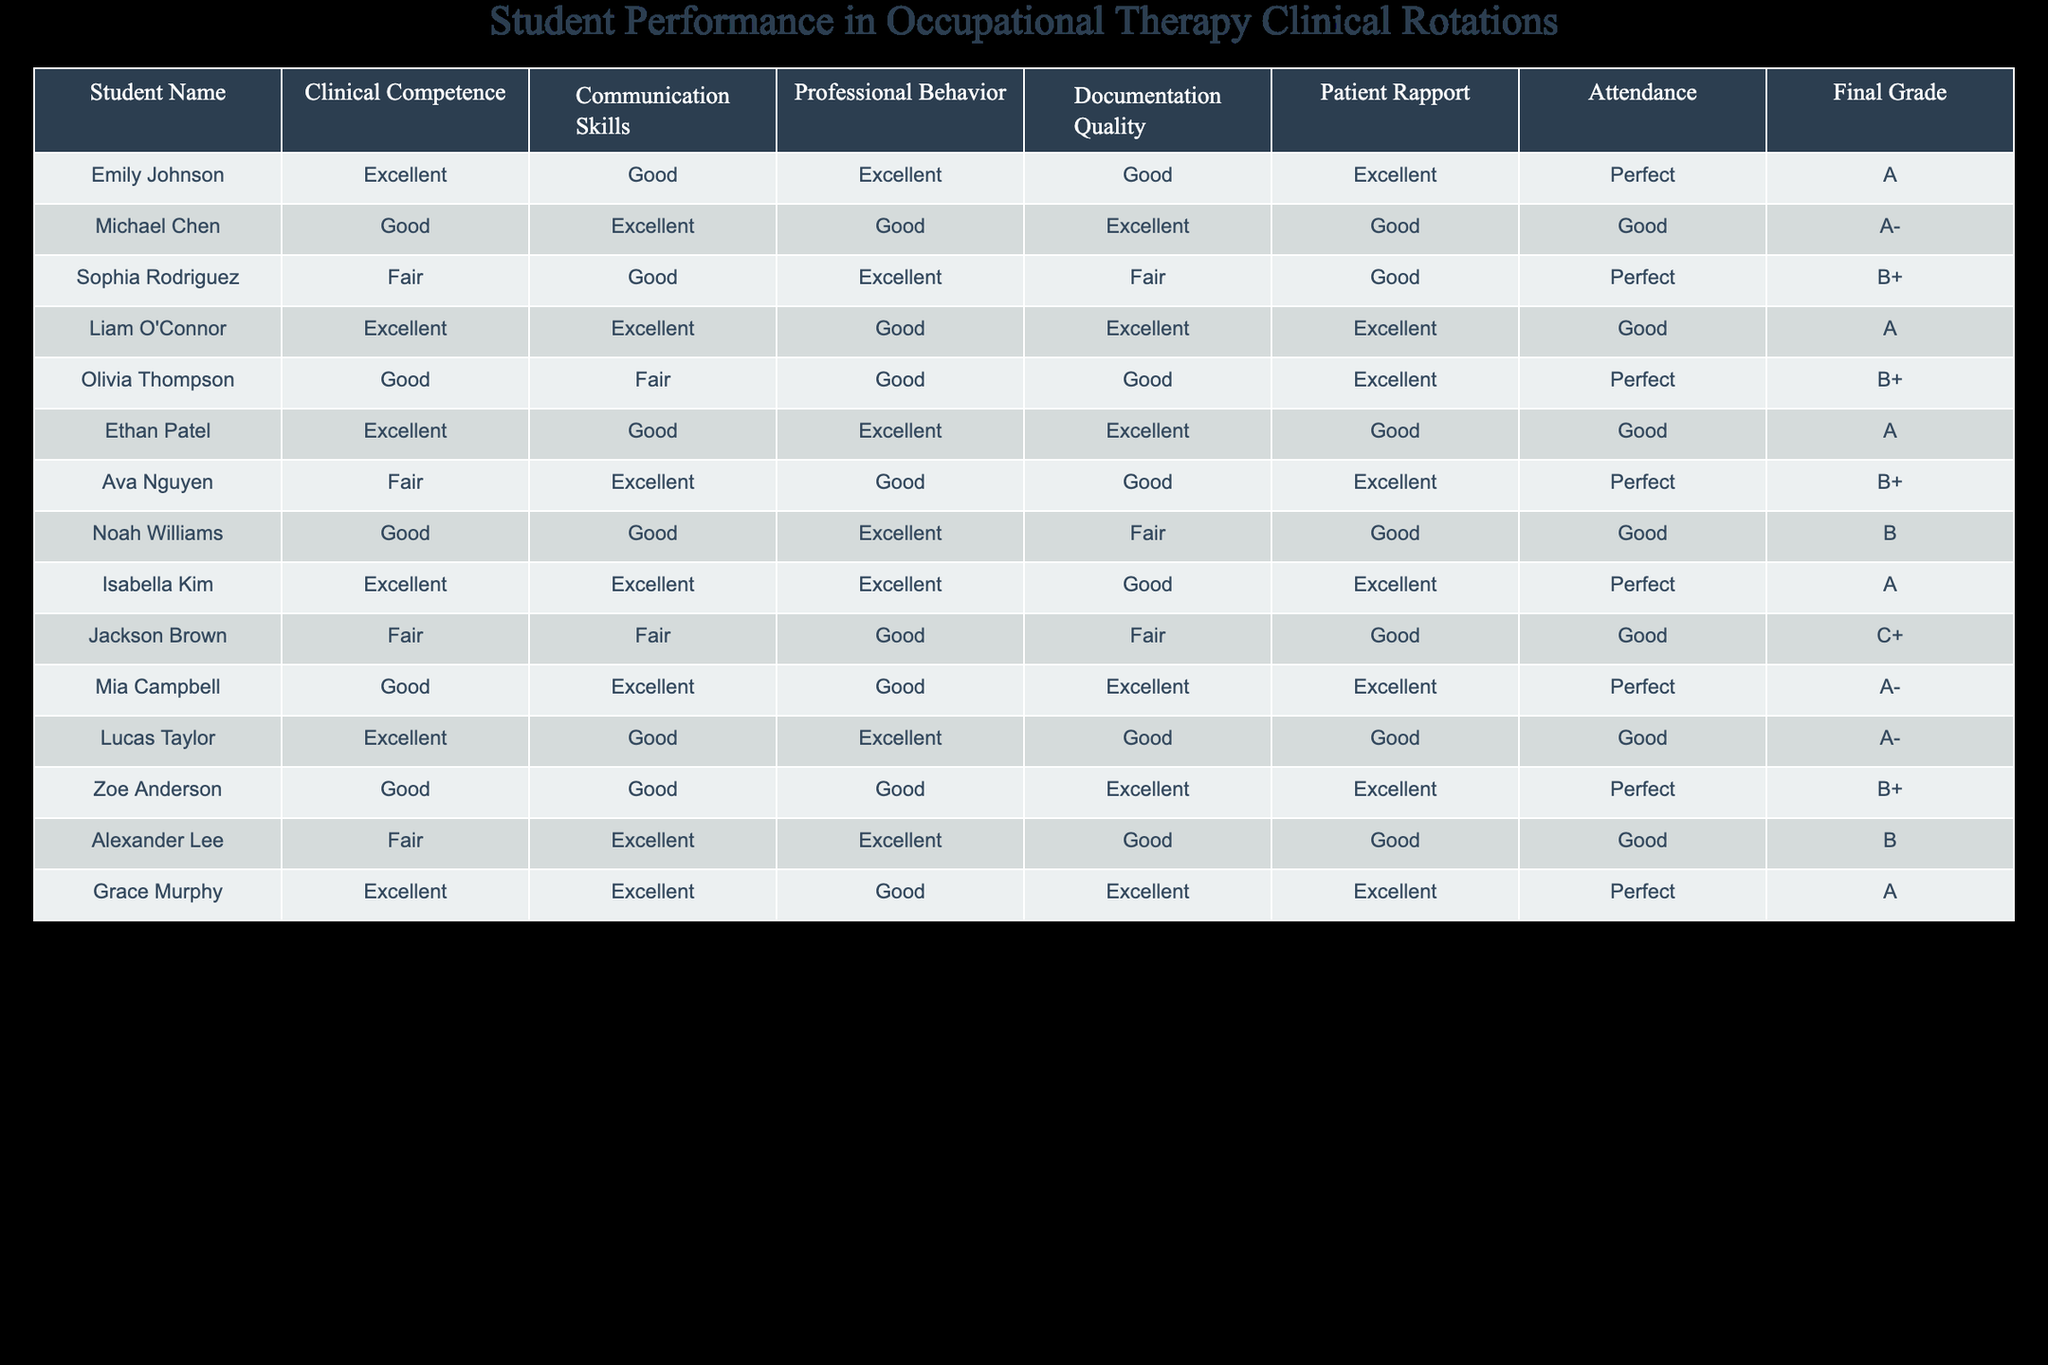What is the final grade of Emily Johnson? Emily Johnson's final grade can be found directly in the table, under the "Final Grade" column. It says "A".
Answer: A How many students have received an A or A- as their final grade? There are four students with final grades of A (Emily Johnson, Liam O'Connor, Isabella Kim, Grace Murphy) and three with an A- (Michael Chen, Mia Campbell, Ethan Patel). Adding these gives us 4 A's + 3 A-'s = 7 students.
Answer: 7 students Who had the best communication skills? Looking at the "Communication Skills" column, the students with "Excellent" as their rating are Michael Chen, Liam O'Connor, Isabella Kim, Grace Murphy, and Ava Nguyen. Any of these students had the best communication skills, and there are five of them.
Answer: 5 students Is there a student with a final grade of C+? The table shows that Jackson Brown has a final grade of C+. Therefore, the answer to this question is yes.
Answer: Yes What is the average score for Patient Rapport among the students? First, we categorize the ratings into numerical values: Excellent = 4, Good = 3, Fair = 2. Then we sum the grades: Excellent (3), Good (6), Fair (2) totaling 27. We divide by 12 (total number of students) and find the average is 27/12 = 2.25, which translates back to Good.
Answer: Good 